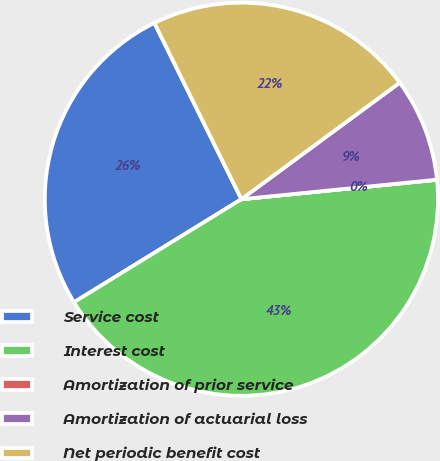Convert chart to OTSL. <chart><loc_0><loc_0><loc_500><loc_500><pie_chart><fcel>Service cost<fcel>Interest cost<fcel>Amortization of prior service<fcel>Amortization of actuarial loss<fcel>Net periodic benefit cost<nl><fcel>26.48%<fcel>42.79%<fcel>0.01%<fcel>8.51%<fcel>22.2%<nl></chart> 